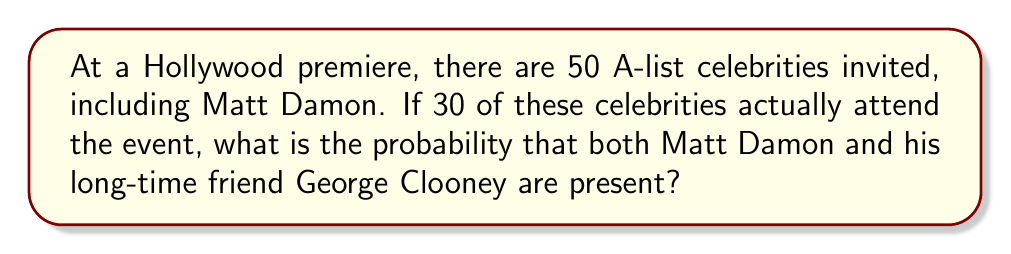Can you solve this math problem? Let's approach this step-by-step:

1) First, we need to calculate the probability of Matt Damon attending:
   $P(\text{Matt}) = \frac{30}{50} = \frac{3}{5}$

2) Now, given that Matt Damon is there, we need to calculate the probability of George Clooney also being there:
   $P(\text{George | Matt}) = \frac{29}{49}$

   This is because if Matt is there, there are 29 spots left out of the remaining 49 celebrities.

3) The probability of both events occurring is the product of these probabilities:

   $$P(\text{Matt and George}) = P(\text{Matt}) \times P(\text{George | Matt})$$

4) Substituting the values:

   $$P(\text{Matt and George}) = \frac{3}{5} \times \frac{29}{49}$$

5) Simplifying:

   $$P(\text{Matt and George}) = \frac{87}{245} \approx 0.3551$$

Therefore, the probability that both Matt Damon and George Clooney attend the premiere is $\frac{87}{245}$ or about 35.51%.
Answer: $\frac{87}{245}$ 